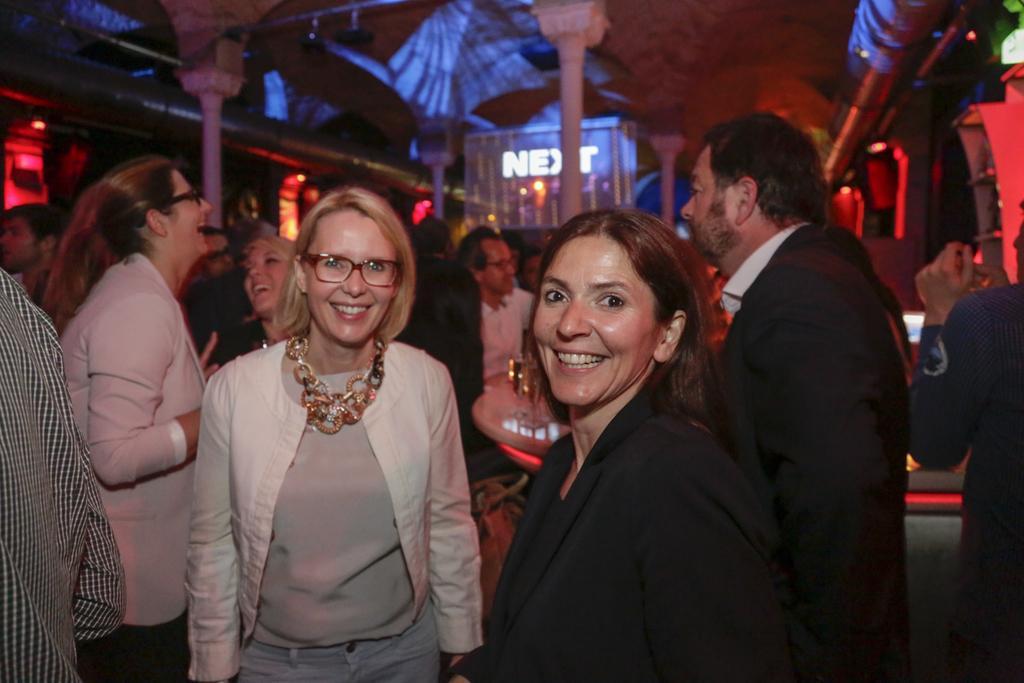Can you describe this image briefly? There are persons in different color dresses on a floor. Some of them are smiling. In the background, there is a hoarding, there are pillars, lights arranged and there is a roof. 